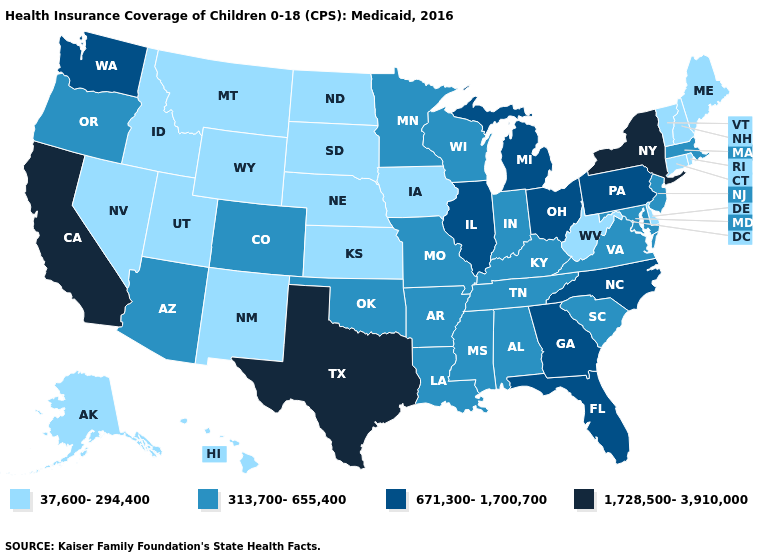Does Kentucky have the highest value in the South?
Answer briefly. No. Which states have the lowest value in the MidWest?
Keep it brief. Iowa, Kansas, Nebraska, North Dakota, South Dakota. What is the value of Virginia?
Answer briefly. 313,700-655,400. Name the states that have a value in the range 671,300-1,700,700?
Quick response, please. Florida, Georgia, Illinois, Michigan, North Carolina, Ohio, Pennsylvania, Washington. What is the value of Illinois?
Concise answer only. 671,300-1,700,700. Name the states that have a value in the range 671,300-1,700,700?
Give a very brief answer. Florida, Georgia, Illinois, Michigan, North Carolina, Ohio, Pennsylvania, Washington. Among the states that border Washington , does Idaho have the highest value?
Short answer required. No. Does Pennsylvania have the lowest value in the Northeast?
Keep it brief. No. Name the states that have a value in the range 313,700-655,400?
Answer briefly. Alabama, Arizona, Arkansas, Colorado, Indiana, Kentucky, Louisiana, Maryland, Massachusetts, Minnesota, Mississippi, Missouri, New Jersey, Oklahoma, Oregon, South Carolina, Tennessee, Virginia, Wisconsin. Among the states that border Missouri , does Oklahoma have the lowest value?
Short answer required. No. Which states hav the highest value in the Northeast?
Answer briefly. New York. What is the value of Utah?
Quick response, please. 37,600-294,400. Which states have the highest value in the USA?
Quick response, please. California, New York, Texas. What is the lowest value in states that border South Carolina?
Short answer required. 671,300-1,700,700. 